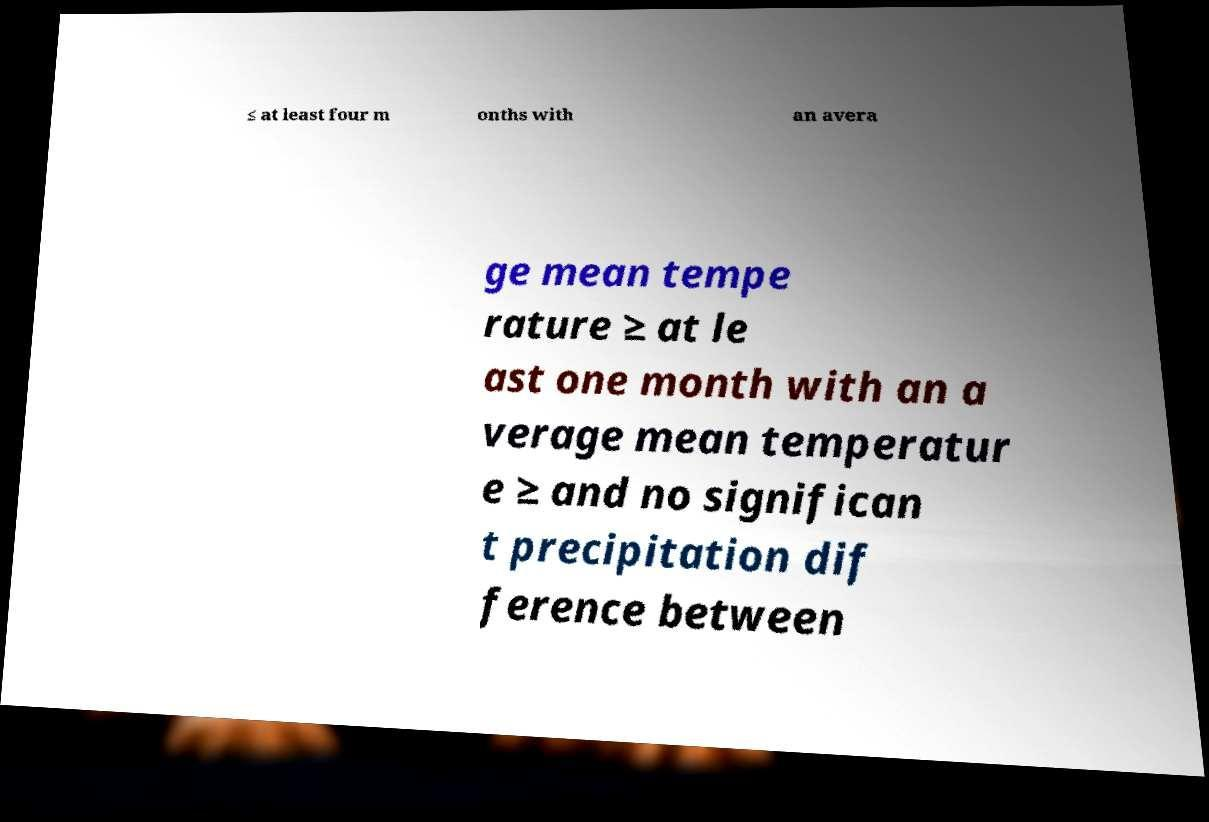Please identify and transcribe the text found in this image. ≤ at least four m onths with an avera ge mean tempe rature ≥ at le ast one month with an a verage mean temperatur e ≥ and no significan t precipitation dif ference between 